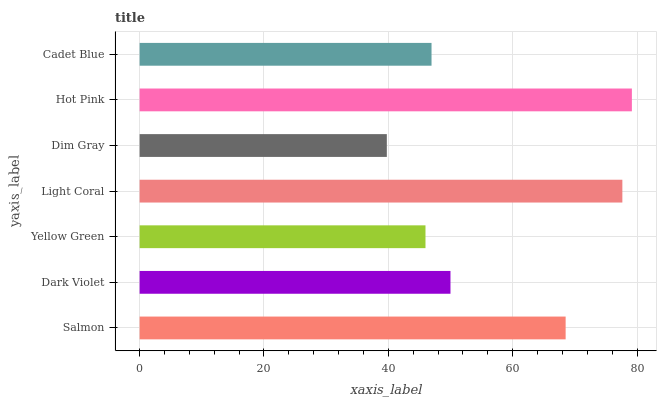Is Dim Gray the minimum?
Answer yes or no. Yes. Is Hot Pink the maximum?
Answer yes or no. Yes. Is Dark Violet the minimum?
Answer yes or no. No. Is Dark Violet the maximum?
Answer yes or no. No. Is Salmon greater than Dark Violet?
Answer yes or no. Yes. Is Dark Violet less than Salmon?
Answer yes or no. Yes. Is Dark Violet greater than Salmon?
Answer yes or no. No. Is Salmon less than Dark Violet?
Answer yes or no. No. Is Dark Violet the high median?
Answer yes or no. Yes. Is Dark Violet the low median?
Answer yes or no. Yes. Is Dim Gray the high median?
Answer yes or no. No. Is Light Coral the low median?
Answer yes or no. No. 